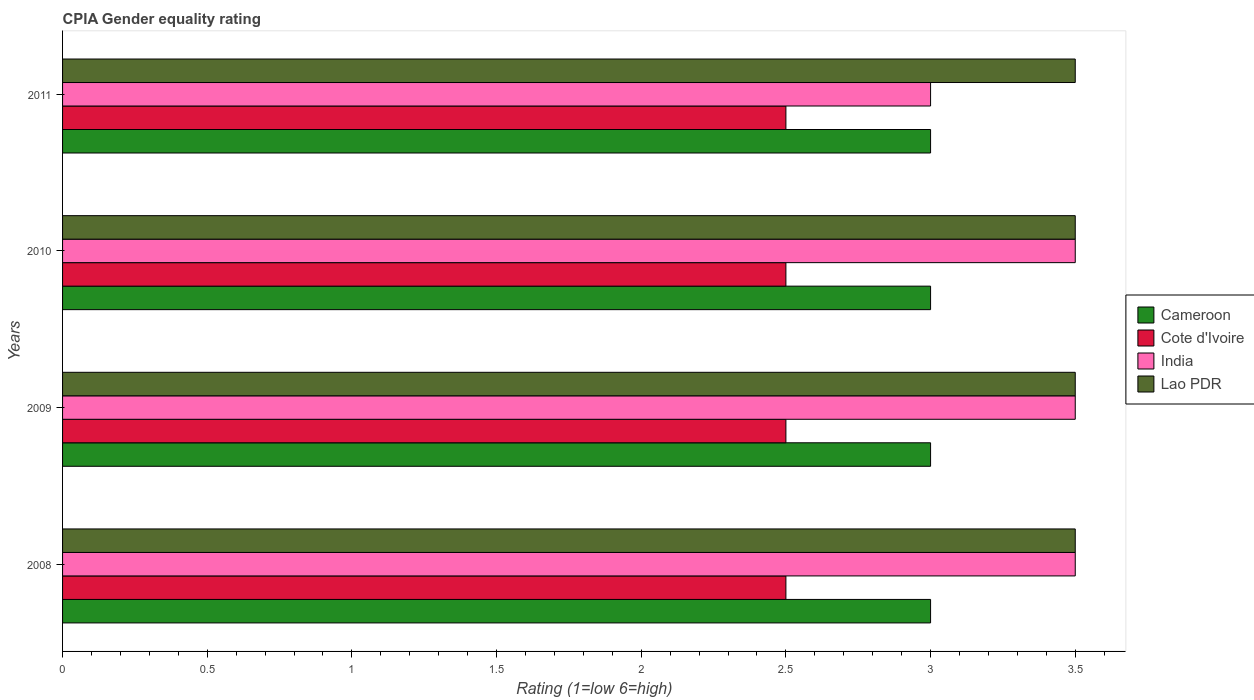How many different coloured bars are there?
Give a very brief answer. 4. How many groups of bars are there?
Offer a terse response. 4. Are the number of bars per tick equal to the number of legend labels?
Keep it short and to the point. Yes. Are the number of bars on each tick of the Y-axis equal?
Your answer should be compact. Yes. How many bars are there on the 2nd tick from the top?
Keep it short and to the point. 4. Across all years, what is the maximum CPIA rating in Cameroon?
Give a very brief answer. 3. Across all years, what is the minimum CPIA rating in Cote d'Ivoire?
Offer a very short reply. 2.5. In which year was the CPIA rating in Cameroon minimum?
Offer a terse response. 2008. What is the total CPIA rating in Cameroon in the graph?
Give a very brief answer. 12. What is the difference between the highest and the second highest CPIA rating in India?
Your answer should be compact. 0. What is the difference between the highest and the lowest CPIA rating in Lao PDR?
Your response must be concise. 0. In how many years, is the CPIA rating in Lao PDR greater than the average CPIA rating in Lao PDR taken over all years?
Keep it short and to the point. 0. What does the 4th bar from the top in 2011 represents?
Your answer should be compact. Cameroon. What does the 4th bar from the bottom in 2011 represents?
Provide a succinct answer. Lao PDR. Is it the case that in every year, the sum of the CPIA rating in Cameroon and CPIA rating in Cote d'Ivoire is greater than the CPIA rating in India?
Your response must be concise. Yes. How many bars are there?
Give a very brief answer. 16. How many years are there in the graph?
Offer a very short reply. 4. What is the difference between two consecutive major ticks on the X-axis?
Your response must be concise. 0.5. Are the values on the major ticks of X-axis written in scientific E-notation?
Offer a terse response. No. Where does the legend appear in the graph?
Offer a very short reply. Center right. What is the title of the graph?
Your answer should be compact. CPIA Gender equality rating. What is the label or title of the X-axis?
Your answer should be very brief. Rating (1=low 6=high). What is the label or title of the Y-axis?
Offer a very short reply. Years. What is the Rating (1=low 6=high) of India in 2008?
Offer a terse response. 3.5. What is the Rating (1=low 6=high) of Lao PDR in 2008?
Keep it short and to the point. 3.5. What is the Rating (1=low 6=high) of Cote d'Ivoire in 2009?
Offer a very short reply. 2.5. What is the Rating (1=low 6=high) in Cameroon in 2010?
Offer a very short reply. 3. What is the Rating (1=low 6=high) in Cameroon in 2011?
Make the answer very short. 3. What is the Rating (1=low 6=high) of Lao PDR in 2011?
Your answer should be very brief. 3.5. Across all years, what is the maximum Rating (1=low 6=high) in Cote d'Ivoire?
Give a very brief answer. 2.5. Across all years, what is the minimum Rating (1=low 6=high) in India?
Offer a terse response. 3. What is the difference between the Rating (1=low 6=high) in Cameroon in 2008 and that in 2009?
Make the answer very short. 0. What is the difference between the Rating (1=low 6=high) of Cote d'Ivoire in 2008 and that in 2009?
Your answer should be very brief. 0. What is the difference between the Rating (1=low 6=high) of Lao PDR in 2008 and that in 2009?
Make the answer very short. 0. What is the difference between the Rating (1=low 6=high) in Cameroon in 2008 and that in 2010?
Keep it short and to the point. 0. What is the difference between the Rating (1=low 6=high) of Cote d'Ivoire in 2008 and that in 2010?
Make the answer very short. 0. What is the difference between the Rating (1=low 6=high) in India in 2008 and that in 2010?
Offer a very short reply. 0. What is the difference between the Rating (1=low 6=high) of Cameroon in 2008 and that in 2011?
Make the answer very short. 0. What is the difference between the Rating (1=low 6=high) of Cote d'Ivoire in 2008 and that in 2011?
Keep it short and to the point. 0. What is the difference between the Rating (1=low 6=high) of India in 2009 and that in 2010?
Offer a terse response. 0. What is the difference between the Rating (1=low 6=high) of Lao PDR in 2009 and that in 2010?
Provide a succinct answer. 0. What is the difference between the Rating (1=low 6=high) in Cote d'Ivoire in 2009 and that in 2011?
Provide a succinct answer. 0. What is the difference between the Rating (1=low 6=high) of Lao PDR in 2009 and that in 2011?
Your answer should be very brief. 0. What is the difference between the Rating (1=low 6=high) of India in 2010 and that in 2011?
Offer a terse response. 0.5. What is the difference between the Rating (1=low 6=high) in Lao PDR in 2010 and that in 2011?
Your response must be concise. 0. What is the difference between the Rating (1=low 6=high) in Cameroon in 2008 and the Rating (1=low 6=high) in India in 2009?
Ensure brevity in your answer.  -0.5. What is the difference between the Rating (1=low 6=high) of Cameroon in 2008 and the Rating (1=low 6=high) of Cote d'Ivoire in 2010?
Your answer should be compact. 0.5. What is the difference between the Rating (1=low 6=high) of Cameroon in 2008 and the Rating (1=low 6=high) of Lao PDR in 2010?
Your answer should be very brief. -0.5. What is the difference between the Rating (1=low 6=high) of Cote d'Ivoire in 2008 and the Rating (1=low 6=high) of Lao PDR in 2010?
Offer a very short reply. -1. What is the difference between the Rating (1=low 6=high) in India in 2008 and the Rating (1=low 6=high) in Lao PDR in 2010?
Make the answer very short. 0. What is the difference between the Rating (1=low 6=high) of Cameroon in 2008 and the Rating (1=low 6=high) of Lao PDR in 2011?
Your answer should be compact. -0.5. What is the difference between the Rating (1=low 6=high) of Cote d'Ivoire in 2008 and the Rating (1=low 6=high) of India in 2011?
Ensure brevity in your answer.  -0.5. What is the difference between the Rating (1=low 6=high) in Cameroon in 2009 and the Rating (1=low 6=high) in Cote d'Ivoire in 2010?
Provide a succinct answer. 0.5. What is the difference between the Rating (1=low 6=high) of Cameroon in 2009 and the Rating (1=low 6=high) of India in 2010?
Offer a terse response. -0.5. What is the difference between the Rating (1=low 6=high) of Cameroon in 2009 and the Rating (1=low 6=high) of Lao PDR in 2010?
Make the answer very short. -0.5. What is the difference between the Rating (1=low 6=high) of Cote d'Ivoire in 2009 and the Rating (1=low 6=high) of India in 2010?
Provide a short and direct response. -1. What is the difference between the Rating (1=low 6=high) in Cote d'Ivoire in 2009 and the Rating (1=low 6=high) in Lao PDR in 2010?
Your response must be concise. -1. What is the difference between the Rating (1=low 6=high) of Cameroon in 2009 and the Rating (1=low 6=high) of Cote d'Ivoire in 2011?
Offer a very short reply. 0.5. What is the difference between the Rating (1=low 6=high) of India in 2009 and the Rating (1=low 6=high) of Lao PDR in 2011?
Offer a terse response. 0. What is the difference between the Rating (1=low 6=high) in Cameroon in 2010 and the Rating (1=low 6=high) in India in 2011?
Your answer should be very brief. 0. What is the average Rating (1=low 6=high) of Cote d'Ivoire per year?
Provide a short and direct response. 2.5. What is the average Rating (1=low 6=high) in India per year?
Offer a terse response. 3.38. What is the average Rating (1=low 6=high) of Lao PDR per year?
Make the answer very short. 3.5. In the year 2008, what is the difference between the Rating (1=low 6=high) in Cameroon and Rating (1=low 6=high) in Cote d'Ivoire?
Offer a very short reply. 0.5. In the year 2008, what is the difference between the Rating (1=low 6=high) in Cote d'Ivoire and Rating (1=low 6=high) in Lao PDR?
Keep it short and to the point. -1. In the year 2009, what is the difference between the Rating (1=low 6=high) of Cameroon and Rating (1=low 6=high) of Lao PDR?
Ensure brevity in your answer.  -0.5. In the year 2009, what is the difference between the Rating (1=low 6=high) of India and Rating (1=low 6=high) of Lao PDR?
Offer a terse response. 0. In the year 2010, what is the difference between the Rating (1=low 6=high) in Cameroon and Rating (1=low 6=high) in Cote d'Ivoire?
Give a very brief answer. 0.5. In the year 2010, what is the difference between the Rating (1=low 6=high) in Cameroon and Rating (1=low 6=high) in India?
Make the answer very short. -0.5. In the year 2010, what is the difference between the Rating (1=low 6=high) of Cameroon and Rating (1=low 6=high) of Lao PDR?
Make the answer very short. -0.5. In the year 2011, what is the difference between the Rating (1=low 6=high) in Cameroon and Rating (1=low 6=high) in Lao PDR?
Your response must be concise. -0.5. In the year 2011, what is the difference between the Rating (1=low 6=high) of Cote d'Ivoire and Rating (1=low 6=high) of India?
Your response must be concise. -0.5. What is the ratio of the Rating (1=low 6=high) in Cameroon in 2008 to that in 2009?
Ensure brevity in your answer.  1. What is the ratio of the Rating (1=low 6=high) of Cote d'Ivoire in 2008 to that in 2009?
Your answer should be compact. 1. What is the ratio of the Rating (1=low 6=high) in India in 2008 to that in 2009?
Offer a terse response. 1. What is the ratio of the Rating (1=low 6=high) of Cote d'Ivoire in 2008 to that in 2010?
Provide a short and direct response. 1. What is the ratio of the Rating (1=low 6=high) of Lao PDR in 2008 to that in 2010?
Provide a succinct answer. 1. What is the ratio of the Rating (1=low 6=high) in Cameroon in 2008 to that in 2011?
Your answer should be very brief. 1. What is the ratio of the Rating (1=low 6=high) of Cote d'Ivoire in 2008 to that in 2011?
Your answer should be very brief. 1. What is the ratio of the Rating (1=low 6=high) of Cameroon in 2009 to that in 2010?
Provide a succinct answer. 1. What is the ratio of the Rating (1=low 6=high) of Cote d'Ivoire in 2009 to that in 2011?
Your response must be concise. 1. What is the ratio of the Rating (1=low 6=high) of India in 2009 to that in 2011?
Your answer should be compact. 1.17. What is the ratio of the Rating (1=low 6=high) of India in 2010 to that in 2011?
Keep it short and to the point. 1.17. What is the ratio of the Rating (1=low 6=high) in Lao PDR in 2010 to that in 2011?
Your response must be concise. 1. What is the difference between the highest and the second highest Rating (1=low 6=high) in India?
Offer a very short reply. 0. What is the difference between the highest and the lowest Rating (1=low 6=high) in Lao PDR?
Your response must be concise. 0. 